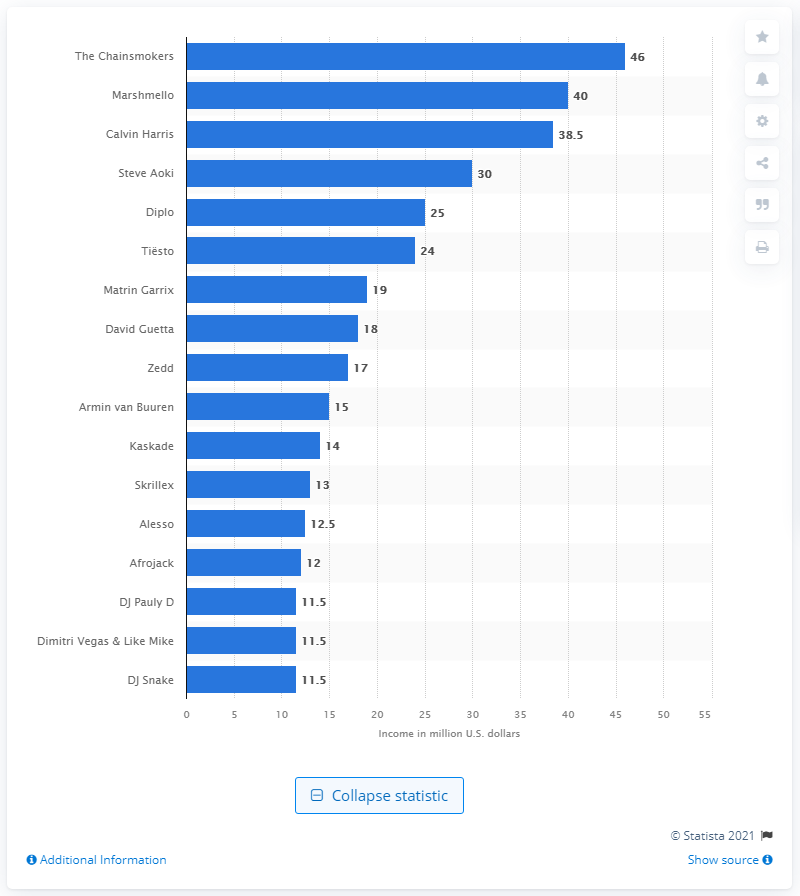List a handful of essential elements in this visual. The annual income of The Chainsmokers was approximately 46 million dollars. The Chainsmokers made an estimated $46 million in 2019. In 2019, Calvin Harris was knocked off the top spot of the highest paid DJs by The Chainsmokers. 